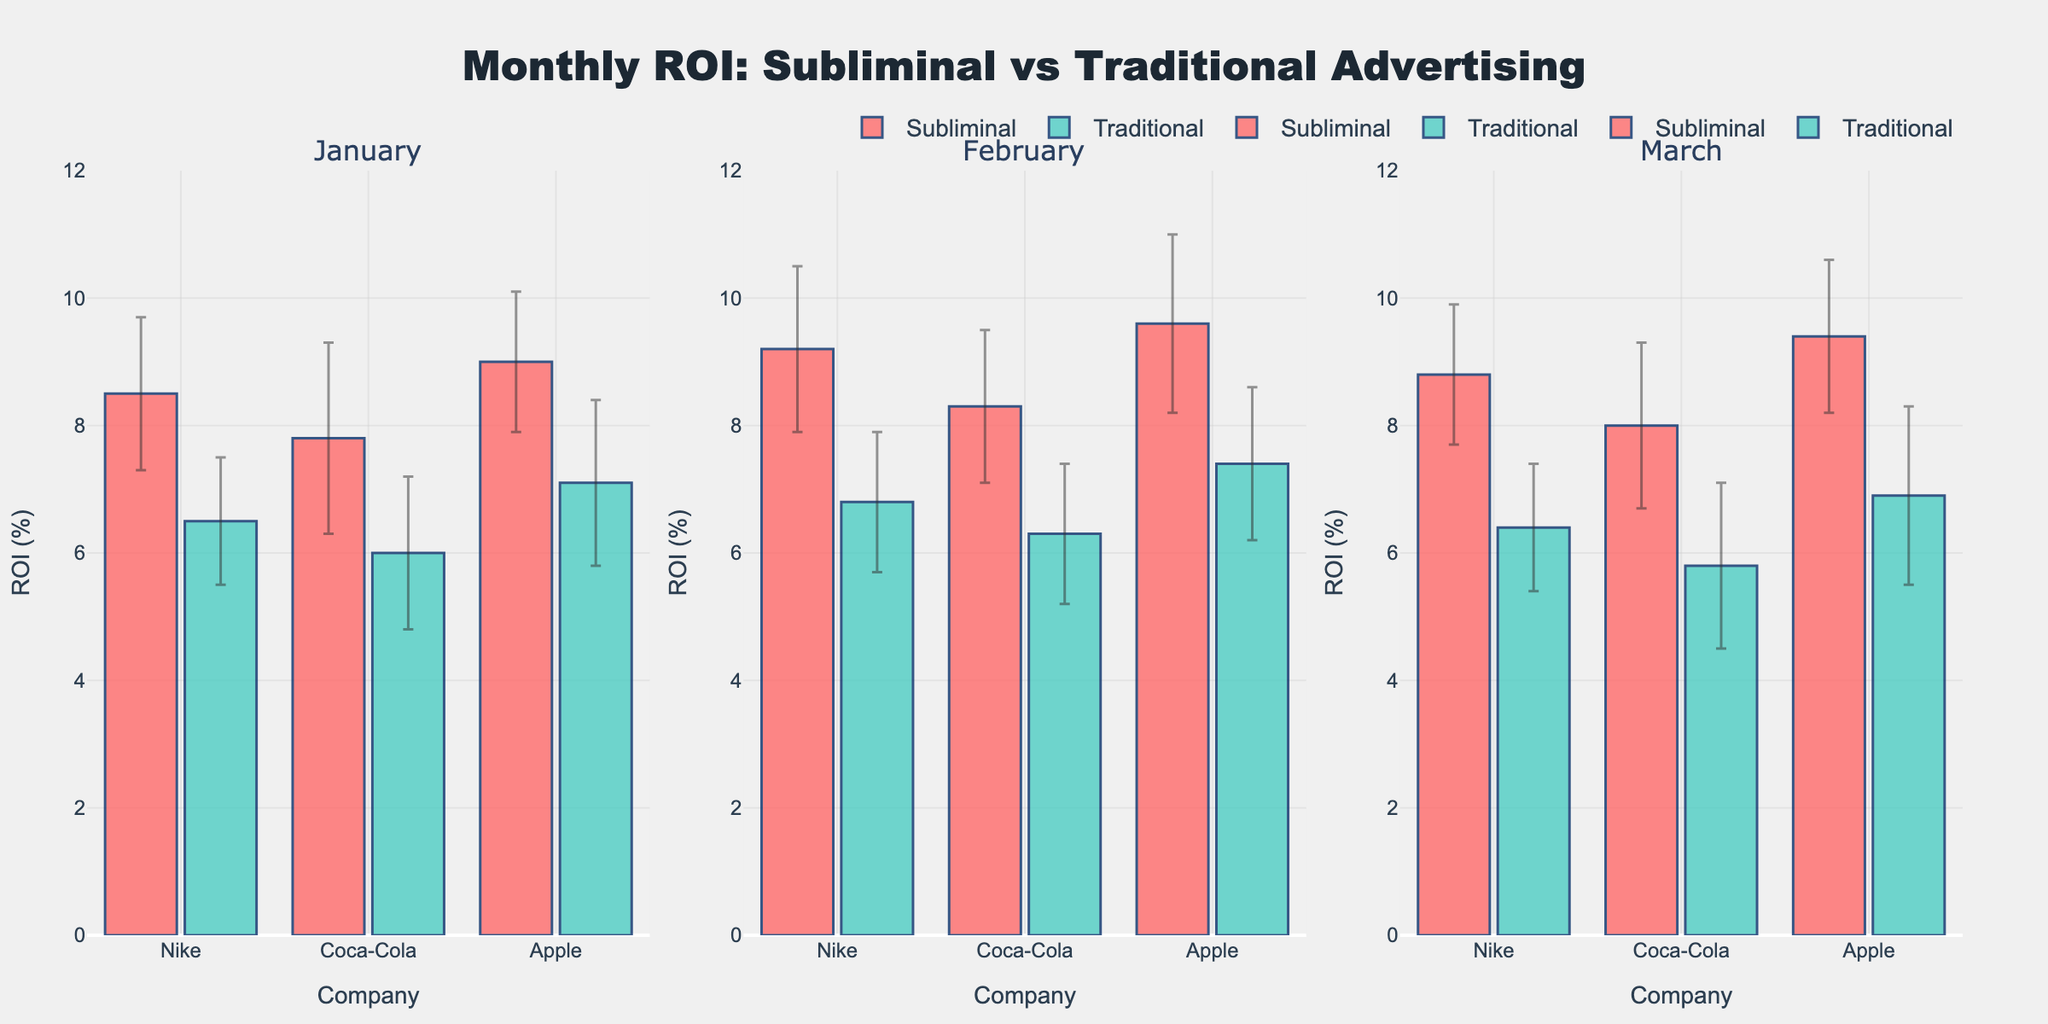What is the title of the plot? The title is clearly displayed at the top center of the plot.
Answer: Monthly ROI: Subliminal vs Traditional Advertising Which company had the highest mean ROI in February using subliminal messaging? Look at the February subplot and identify the tallest bar for subliminal messaging.
Answer: Apple Which campaign type generally shows a higher ROI across all months? Compare the heights of the bars of both Subliminal and Traditional campaigns across January, February, and March.
Answer: Subliminal What's the average ROI of Nike's traditional campaigns over the three months? Sum up the ROI values for Nike in the traditional campaign category over January, February, and March and divide by the number of months: (6.5 + 6.8 + 6.4)/3 = 6.57
Answer: 6.57 How does Apple's ROI in March using subliminal messaging compare to Coca-Cola's ROI in February using the same method? Compare the height of the bar for Apple in March to the height of the bar for Coca-Cola in February, both in subliminal messaging. Apple's March (9.4) is higher than Coca-Cola’s February (8.3).
Answer: Apple’s ROI is higher What is the mean ROI difference between Nike’s subminimal and traditional campaigns in January? Subtract the mean ROI of the traditional campaign from the mean ROI of the subliminal campaign for Nike in January: 8.5 - 6.5 = 2.0.
Answer: 2.0 Which month shows the largest variability in Apple's ROI using subliminal messaging, based on error bars? The error bars indicate standard deviation. Compare the height of the error bars for Apple across January, February, and March within the subliminal category.
Answer: February What is the overall trend of Coca-Cola's ROI using subliminal messaging from January to March? Observe the bars for Coca-Cola using subliminal campaigns across the three subplots to determine if they increase, decrease, or stay constant: 7.8 (Jan.), 8.3 (Feb.), 8.0 (Mar.). The trend is an initial increase followed by a slight decrease.
Answer: Initial increase followed by a slight decrease Which company and campaign type has the smallest standard error in January? The smallest error bar (shortest vertical line) in January, indicating the smallest standard deviation. Subliminal Apple’s error is 1.1.
Answer: Apple’s subliminal campaign How do the error bars of traditional campaigns compare to subliminal campaigns across all months? Examine and compare the lengths of the error bars (standard deviations) for traditional and subliminal campaigns across January, February, and March: generally, traditional campaigns have shorter error bars than subliminal campaigns.
Answer: Traditional campaigns generally have shorter error bars 